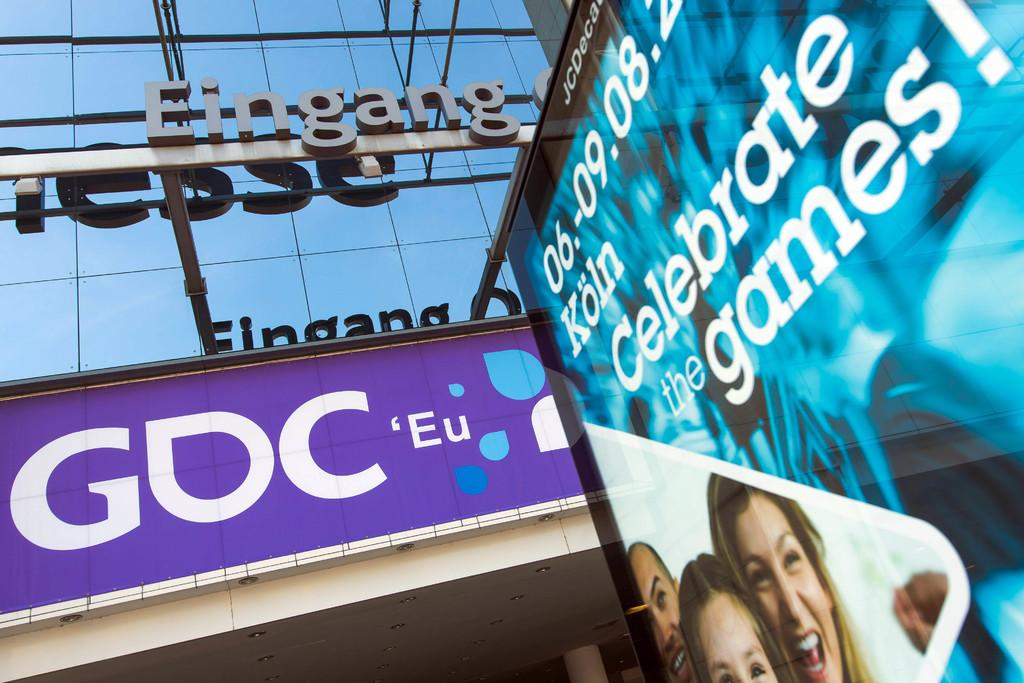What type of material is used for the building wall in the image? The building wall in the image has glass. What word is written on the building wall? The name "EINGANG" is written on the building wall. What can be seen near the building wall in the image? There is a hoarding with an advertisement near the building wall. How many pizzas can be seen on the building wall in the image? There are no pizzas present on the building wall in the image. What type of balance is required to stand on the building wall in the image? There is no person standing on the building wall in the image, so the question of balance is not applicable. 